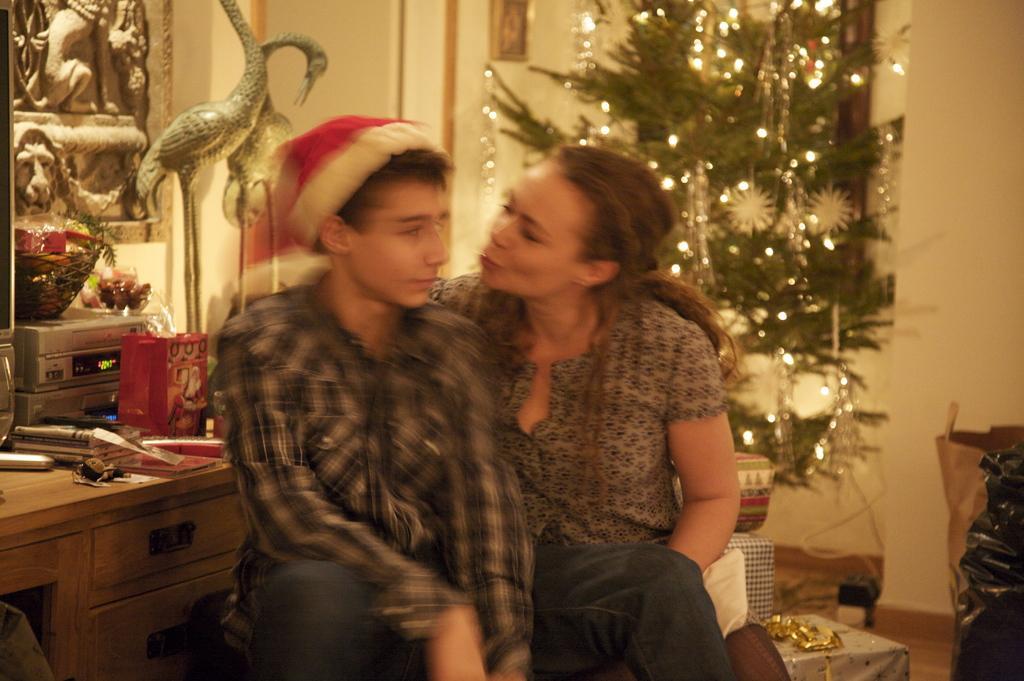Describe this image in one or two sentences. There is a boy and a woman in this picture sitting. The boy is wearing a hat on his head. In the background there are some trees and lighting. There are some toys here. In the background there is a wall. 